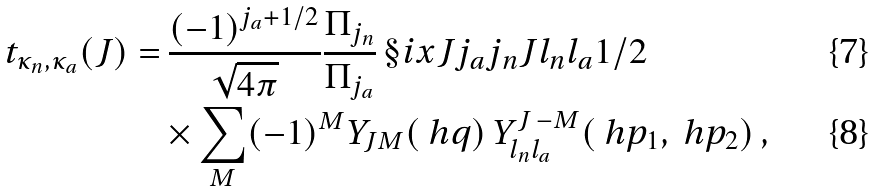<formula> <loc_0><loc_0><loc_500><loc_500>t _ { \kappa _ { n } , \kappa _ { a } } ( J ) = & \ \frac { ( - 1 ) ^ { j _ { a } + 1 / 2 } } { \sqrt { 4 \pi } } \frac { \Pi _ { j _ { n } } } { \Pi _ { j _ { a } } } \, \S i x J { j _ { a } } { j _ { n } } { J } { l _ { n } } { l _ { a } } { 1 / 2 } \, \\ & \times \sum _ { M } ( - 1 ) ^ { M } Y _ { J M } ( \ h q ) \, Y ^ { J \, - M } _ { l _ { n } l _ { a } } ( \ h p _ { 1 } , \ h p _ { 2 } ) \, ,</formula> 